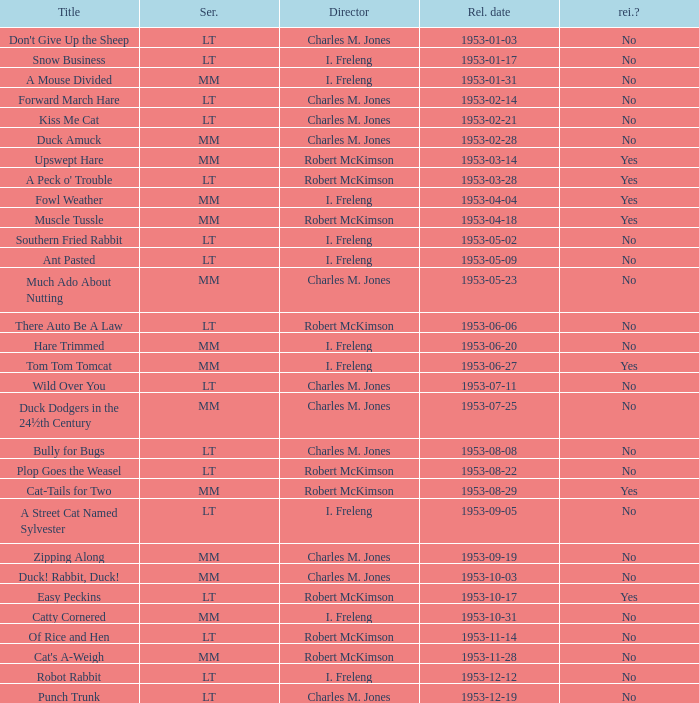What's the title for the release date of 1953-01-31 in the MM series, no reissue, and a director of I. Freleng? A Mouse Divided. 